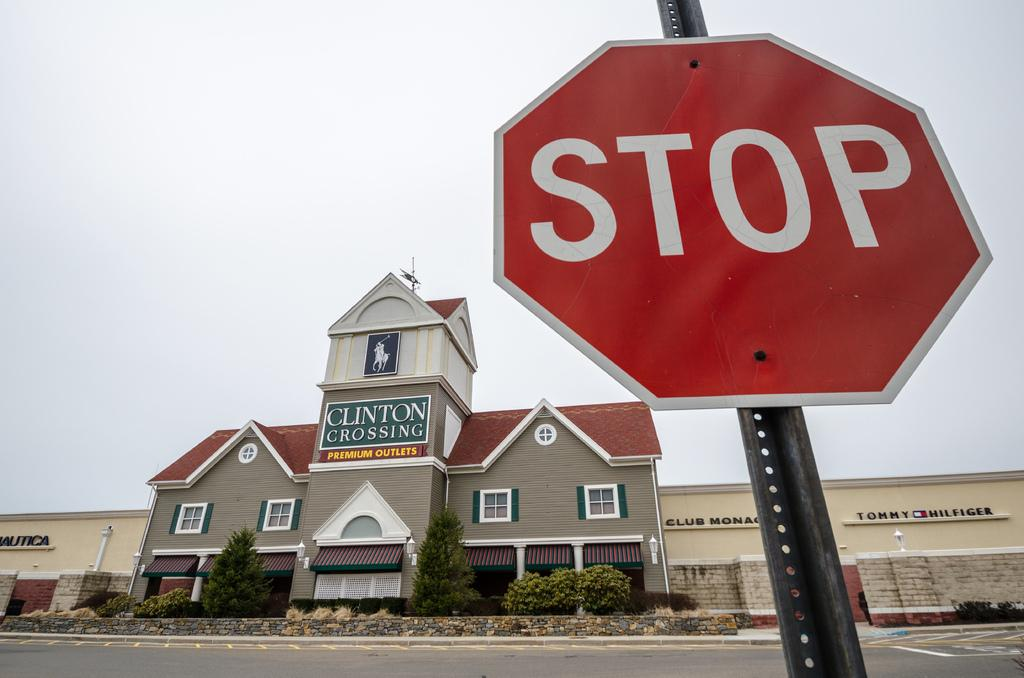Provide a one-sentence caption for the provided image. Clinton crossing premium outlet building with a stop sign in front. 